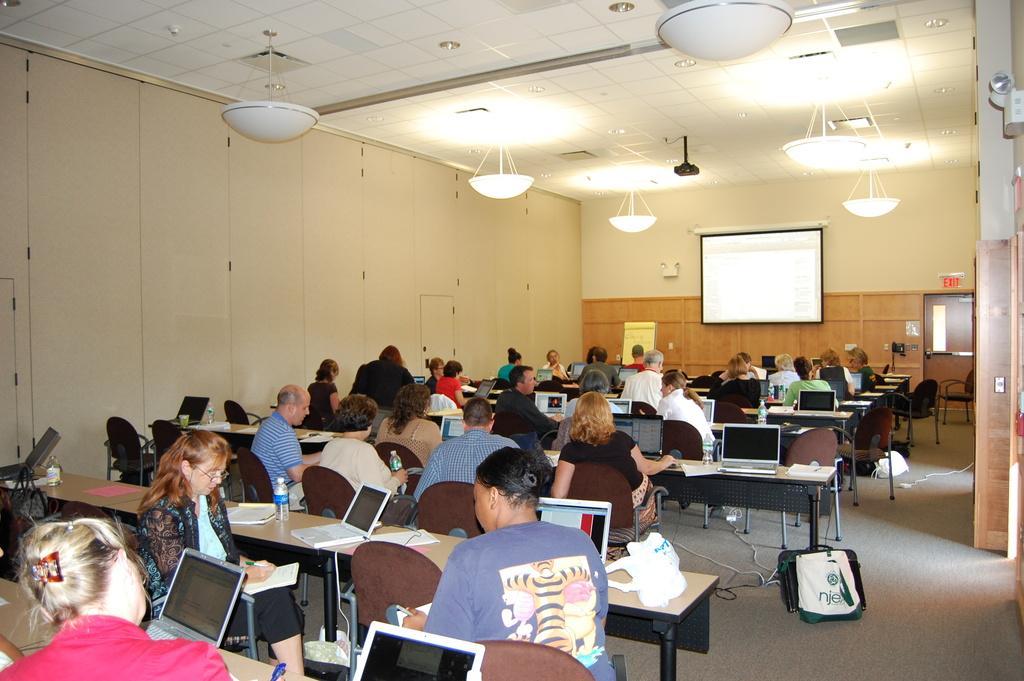Can you describe this image briefly? This picture shows a group of people seated on the chairs with the laptops on the table and we see a projector screen on the wall and few lights 